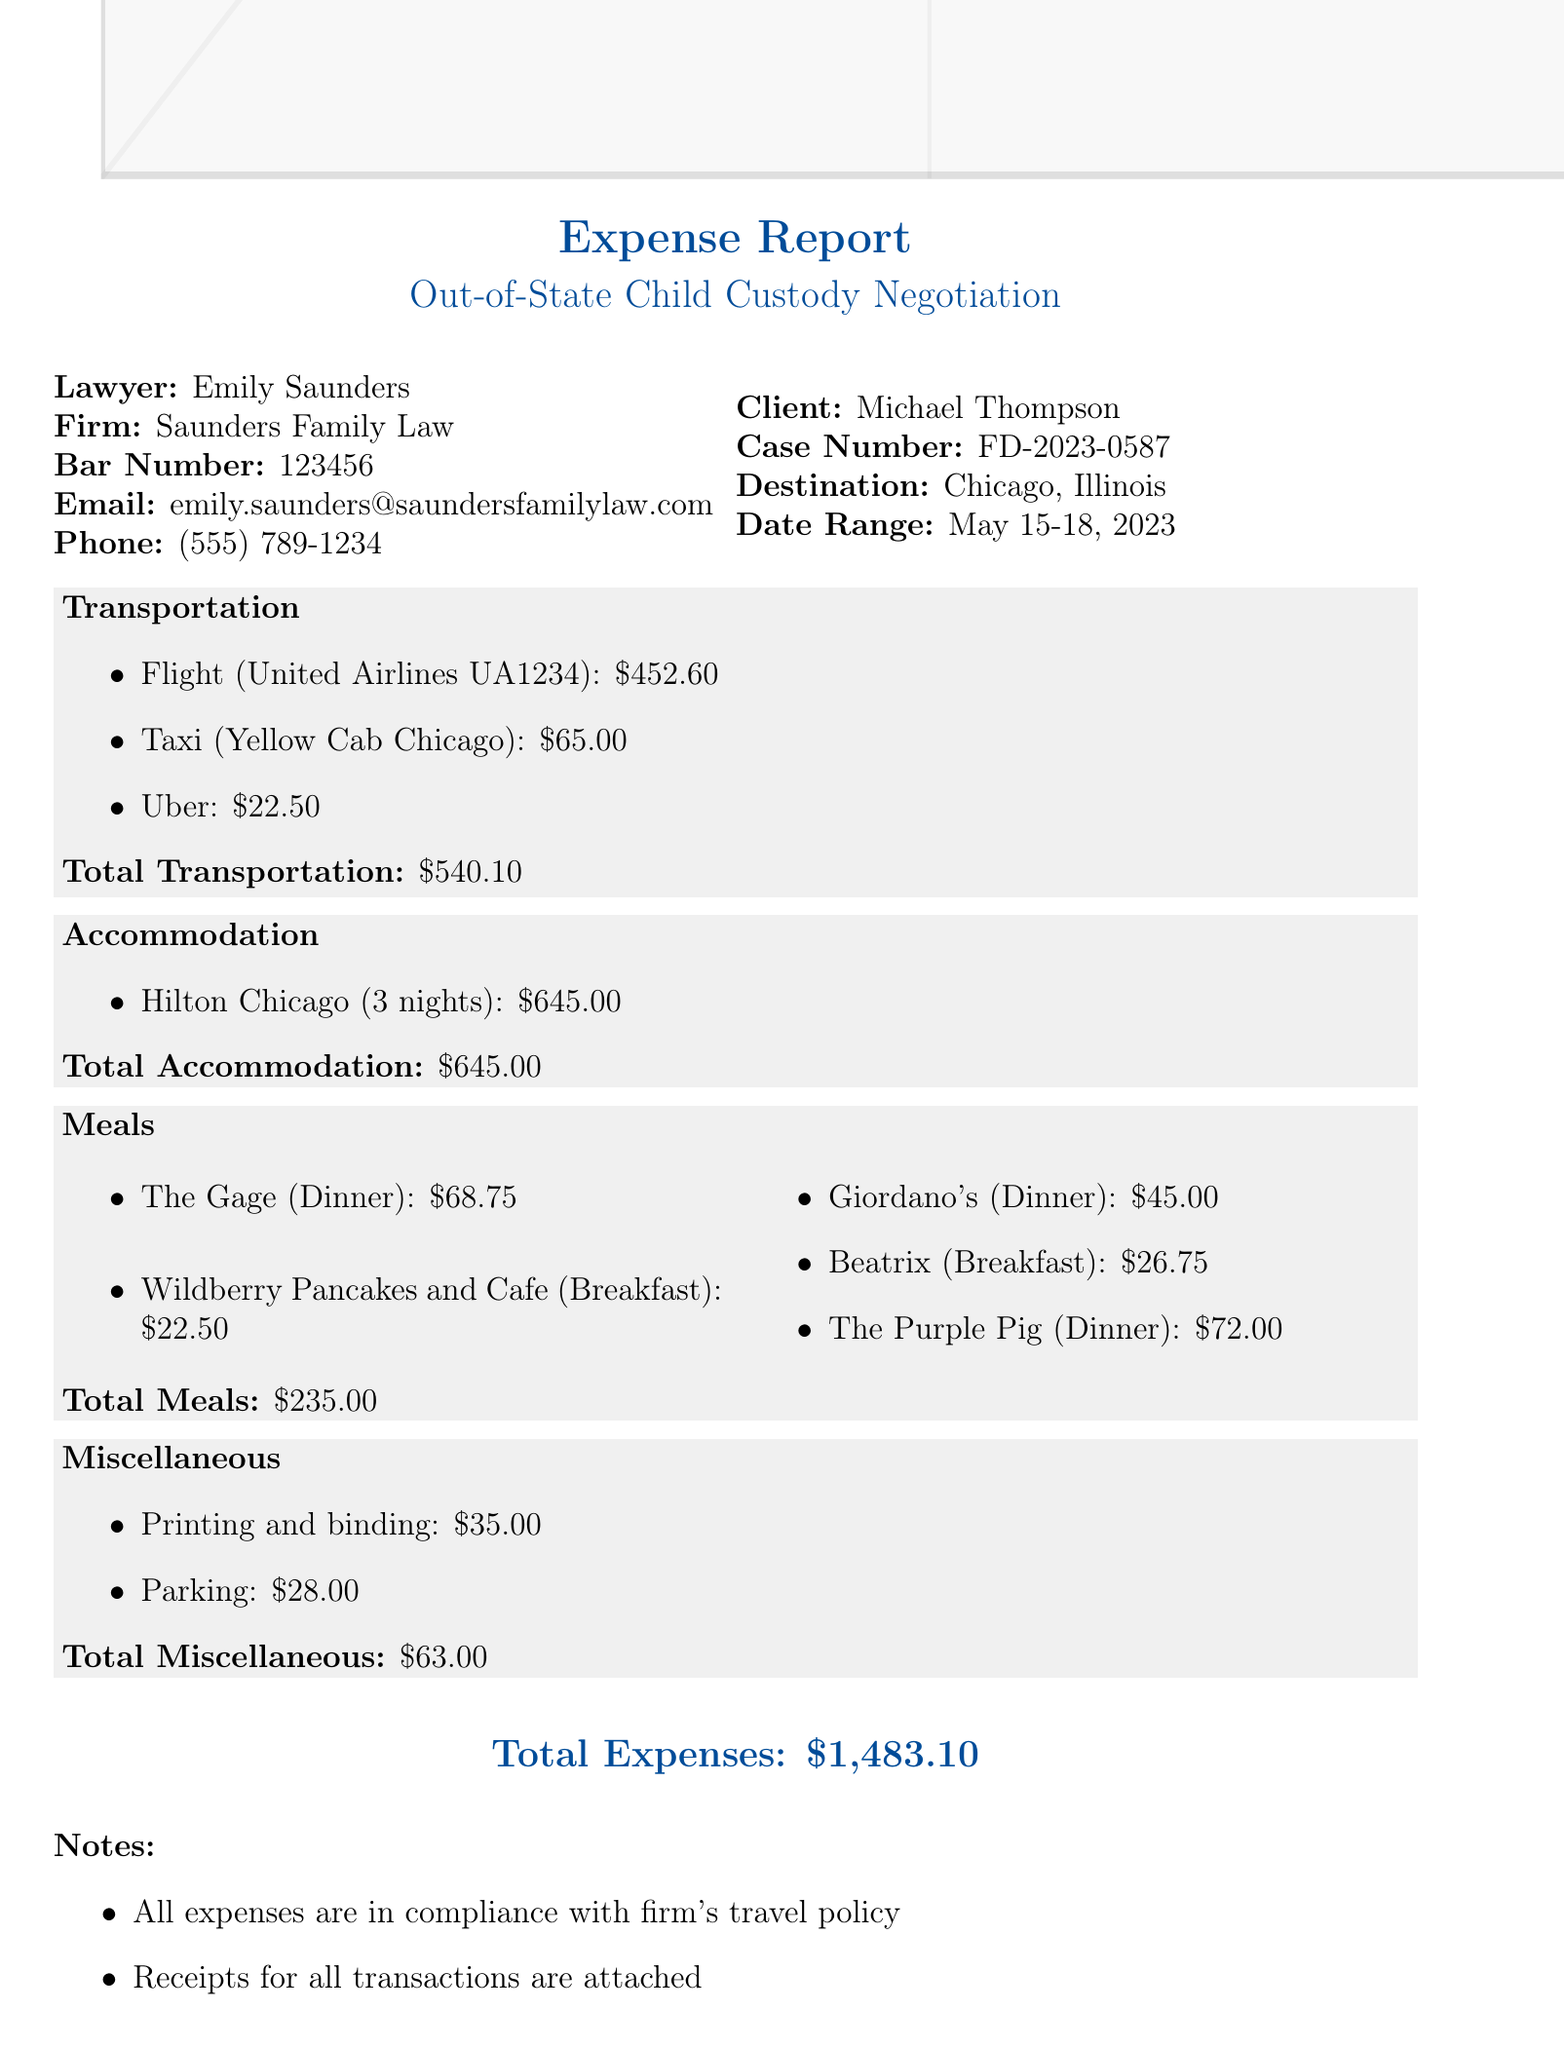What is the name of the lawyer? The lawyer's name is listed at the top of the document under "Lawyer," which is Emily Saunders.
Answer: Emily Saunders What is the total accommodation cost? The total accommodation cost is explicitly mentioned in the section dedicated to accommodation costs, which lists a total of $645.00.
Answer: $645.00 What is the purpose of the travel? The document specifies that the travel purpose is for an out-of-state child custody negotiation.
Answer: Out-of-state child custody negotiation How many nights was the accommodation? The accommodation section states it was for 3 nights at the Hilton Chicago, clearly specifying the length of stay.
Answer: 3 nights What is the total cost for transportation? The transportation section provides a summary stating the total transportation cost to be $540.10, which is the sum of individual transportation expenses.
Answer: $540.10 Which hotel was used for accommodation? The accommodation section lists the name of the hotel where the lawyer stayed during the trip, which is the Hilton Chicago.
Answer: Hilton Chicago What was the cost of printing and binding? In the miscellaneous expenses section, it specifically states that the cost of printing and binding was $35.00.
Answer: $35.00 What was the total meal expense? The document sums up the meal expenses to a total of $235.00, clearly indicated in the meals section.
Answer: $235.00 What was the date range of travel? The date range for the travel is clearly indicated in the client information section as May 15-18, 2023.
Answer: May 15-18, 2023 